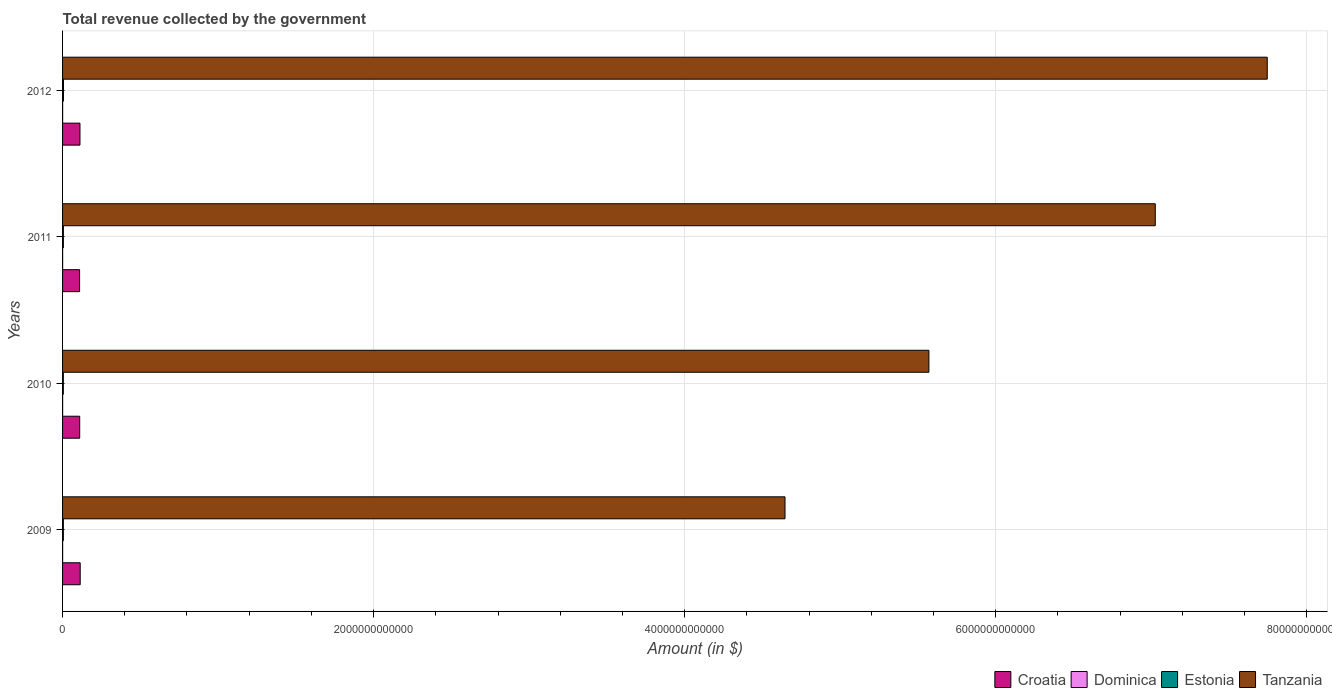Are the number of bars per tick equal to the number of legend labels?
Your answer should be very brief. Yes. What is the label of the 3rd group of bars from the top?
Offer a very short reply. 2010. What is the total revenue collected by the government in Estonia in 2009?
Provide a succinct answer. 5.06e+09. Across all years, what is the maximum total revenue collected by the government in Dominica?
Make the answer very short. 3.57e+08. Across all years, what is the minimum total revenue collected by the government in Tanzania?
Provide a short and direct response. 4.65e+12. In which year was the total revenue collected by the government in Croatia minimum?
Give a very brief answer. 2011. What is the total total revenue collected by the government in Croatia in the graph?
Your response must be concise. 4.45e+11. What is the difference between the total revenue collected by the government in Estonia in 2009 and that in 2012?
Offer a terse response. -7.36e+08. What is the difference between the total revenue collected by the government in Croatia in 2010 and the total revenue collected by the government in Estonia in 2009?
Your answer should be compact. 1.05e+11. What is the average total revenue collected by the government in Dominica per year?
Ensure brevity in your answer.  3.52e+08. In the year 2011, what is the difference between the total revenue collected by the government in Dominica and total revenue collected by the government in Croatia?
Give a very brief answer. -1.09e+11. What is the ratio of the total revenue collected by the government in Dominica in 2010 to that in 2012?
Offer a terse response. 1.01. Is the total revenue collected by the government in Tanzania in 2010 less than that in 2012?
Your answer should be compact. Yes. Is the difference between the total revenue collected by the government in Dominica in 2010 and 2011 greater than the difference between the total revenue collected by the government in Croatia in 2010 and 2011?
Keep it short and to the point. No. What is the difference between the highest and the second highest total revenue collected by the government in Dominica?
Your answer should be very brief. 5.50e+06. What is the difference between the highest and the lowest total revenue collected by the government in Estonia?
Keep it short and to the point. 8.42e+08. In how many years, is the total revenue collected by the government in Croatia greater than the average total revenue collected by the government in Croatia taken over all years?
Keep it short and to the point. 2. Is it the case that in every year, the sum of the total revenue collected by the government in Croatia and total revenue collected by the government in Estonia is greater than the sum of total revenue collected by the government in Dominica and total revenue collected by the government in Tanzania?
Your response must be concise. No. What does the 1st bar from the top in 2011 represents?
Offer a very short reply. Tanzania. What does the 4th bar from the bottom in 2009 represents?
Your response must be concise. Tanzania. Is it the case that in every year, the sum of the total revenue collected by the government in Estonia and total revenue collected by the government in Tanzania is greater than the total revenue collected by the government in Croatia?
Provide a succinct answer. Yes. How many bars are there?
Offer a terse response. 16. How many years are there in the graph?
Provide a succinct answer. 4. What is the difference between two consecutive major ticks on the X-axis?
Give a very brief answer. 2.00e+12. What is the title of the graph?
Provide a succinct answer. Total revenue collected by the government. Does "Latin America(developing only)" appear as one of the legend labels in the graph?
Your answer should be very brief. No. What is the label or title of the X-axis?
Keep it short and to the point. Amount (in $). What is the Amount (in $) in Croatia in 2009?
Offer a very short reply. 1.13e+11. What is the Amount (in $) in Dominica in 2009?
Your response must be concise. 3.50e+08. What is the Amount (in $) in Estonia in 2009?
Keep it short and to the point. 5.06e+09. What is the Amount (in $) of Tanzania in 2009?
Provide a short and direct response. 4.65e+12. What is the Amount (in $) in Croatia in 2010?
Give a very brief answer. 1.10e+11. What is the Amount (in $) in Dominica in 2010?
Keep it short and to the point. 3.52e+08. What is the Amount (in $) of Estonia in 2010?
Give a very brief answer. 4.96e+09. What is the Amount (in $) of Tanzania in 2010?
Make the answer very short. 5.57e+12. What is the Amount (in $) of Croatia in 2011?
Offer a terse response. 1.10e+11. What is the Amount (in $) of Dominica in 2011?
Provide a short and direct response. 3.57e+08. What is the Amount (in $) in Estonia in 2011?
Make the answer very short. 5.31e+09. What is the Amount (in $) of Tanzania in 2011?
Give a very brief answer. 7.03e+12. What is the Amount (in $) in Croatia in 2012?
Make the answer very short. 1.12e+11. What is the Amount (in $) of Dominica in 2012?
Keep it short and to the point. 3.49e+08. What is the Amount (in $) in Estonia in 2012?
Provide a short and direct response. 5.80e+09. What is the Amount (in $) of Tanzania in 2012?
Offer a terse response. 7.75e+12. Across all years, what is the maximum Amount (in $) of Croatia?
Provide a short and direct response. 1.13e+11. Across all years, what is the maximum Amount (in $) of Dominica?
Provide a short and direct response. 3.57e+08. Across all years, what is the maximum Amount (in $) of Estonia?
Your answer should be very brief. 5.80e+09. Across all years, what is the maximum Amount (in $) in Tanzania?
Keep it short and to the point. 7.75e+12. Across all years, what is the minimum Amount (in $) in Croatia?
Provide a short and direct response. 1.10e+11. Across all years, what is the minimum Amount (in $) of Dominica?
Your answer should be compact. 3.49e+08. Across all years, what is the minimum Amount (in $) in Estonia?
Your answer should be compact. 4.96e+09. Across all years, what is the minimum Amount (in $) in Tanzania?
Make the answer very short. 4.65e+12. What is the total Amount (in $) in Croatia in the graph?
Offer a very short reply. 4.45e+11. What is the total Amount (in $) in Dominica in the graph?
Make the answer very short. 1.41e+09. What is the total Amount (in $) of Estonia in the graph?
Ensure brevity in your answer.  2.11e+1. What is the total Amount (in $) in Tanzania in the graph?
Keep it short and to the point. 2.50e+13. What is the difference between the Amount (in $) in Croatia in 2009 and that in 2010?
Your answer should be very brief. 3.26e+09. What is the difference between the Amount (in $) in Dominica in 2009 and that in 2010?
Offer a terse response. -1.80e+06. What is the difference between the Amount (in $) in Estonia in 2009 and that in 2010?
Your answer should be compact. 1.06e+08. What is the difference between the Amount (in $) in Tanzania in 2009 and that in 2010?
Offer a terse response. -9.25e+11. What is the difference between the Amount (in $) in Croatia in 2009 and that in 2011?
Keep it short and to the point. 3.93e+09. What is the difference between the Amount (in $) in Dominica in 2009 and that in 2011?
Provide a short and direct response. -7.30e+06. What is the difference between the Amount (in $) of Estonia in 2009 and that in 2011?
Offer a very short reply. -2.50e+08. What is the difference between the Amount (in $) in Tanzania in 2009 and that in 2011?
Ensure brevity in your answer.  -2.38e+12. What is the difference between the Amount (in $) of Croatia in 2009 and that in 2012?
Offer a very short reply. 1.54e+09. What is the difference between the Amount (in $) in Estonia in 2009 and that in 2012?
Your answer should be compact. -7.36e+08. What is the difference between the Amount (in $) in Tanzania in 2009 and that in 2012?
Make the answer very short. -3.10e+12. What is the difference between the Amount (in $) of Croatia in 2010 and that in 2011?
Your answer should be very brief. 6.73e+08. What is the difference between the Amount (in $) of Dominica in 2010 and that in 2011?
Provide a succinct answer. -5.50e+06. What is the difference between the Amount (in $) of Estonia in 2010 and that in 2011?
Your answer should be very brief. -3.56e+08. What is the difference between the Amount (in $) of Tanzania in 2010 and that in 2011?
Your answer should be compact. -1.46e+12. What is the difference between the Amount (in $) of Croatia in 2010 and that in 2012?
Your answer should be very brief. -1.72e+09. What is the difference between the Amount (in $) in Dominica in 2010 and that in 2012?
Give a very brief answer. 2.60e+06. What is the difference between the Amount (in $) of Estonia in 2010 and that in 2012?
Give a very brief answer. -8.42e+08. What is the difference between the Amount (in $) in Tanzania in 2010 and that in 2012?
Your answer should be compact. -2.18e+12. What is the difference between the Amount (in $) in Croatia in 2011 and that in 2012?
Your response must be concise. -2.40e+09. What is the difference between the Amount (in $) in Dominica in 2011 and that in 2012?
Give a very brief answer. 8.10e+06. What is the difference between the Amount (in $) of Estonia in 2011 and that in 2012?
Give a very brief answer. -4.86e+08. What is the difference between the Amount (in $) in Tanzania in 2011 and that in 2012?
Make the answer very short. -7.20e+11. What is the difference between the Amount (in $) of Croatia in 2009 and the Amount (in $) of Dominica in 2010?
Provide a succinct answer. 1.13e+11. What is the difference between the Amount (in $) in Croatia in 2009 and the Amount (in $) in Estonia in 2010?
Offer a very short reply. 1.08e+11. What is the difference between the Amount (in $) in Croatia in 2009 and the Amount (in $) in Tanzania in 2010?
Offer a very short reply. -5.46e+12. What is the difference between the Amount (in $) of Dominica in 2009 and the Amount (in $) of Estonia in 2010?
Make the answer very short. -4.61e+09. What is the difference between the Amount (in $) in Dominica in 2009 and the Amount (in $) in Tanzania in 2010?
Offer a terse response. -5.57e+12. What is the difference between the Amount (in $) in Estonia in 2009 and the Amount (in $) in Tanzania in 2010?
Your answer should be compact. -5.57e+12. What is the difference between the Amount (in $) of Croatia in 2009 and the Amount (in $) of Dominica in 2011?
Your answer should be very brief. 1.13e+11. What is the difference between the Amount (in $) of Croatia in 2009 and the Amount (in $) of Estonia in 2011?
Offer a very short reply. 1.08e+11. What is the difference between the Amount (in $) in Croatia in 2009 and the Amount (in $) in Tanzania in 2011?
Ensure brevity in your answer.  -6.91e+12. What is the difference between the Amount (in $) of Dominica in 2009 and the Amount (in $) of Estonia in 2011?
Your answer should be compact. -4.96e+09. What is the difference between the Amount (in $) of Dominica in 2009 and the Amount (in $) of Tanzania in 2011?
Provide a succinct answer. -7.03e+12. What is the difference between the Amount (in $) of Estonia in 2009 and the Amount (in $) of Tanzania in 2011?
Keep it short and to the point. -7.02e+12. What is the difference between the Amount (in $) of Croatia in 2009 and the Amount (in $) of Dominica in 2012?
Your answer should be compact. 1.13e+11. What is the difference between the Amount (in $) in Croatia in 2009 and the Amount (in $) in Estonia in 2012?
Offer a terse response. 1.08e+11. What is the difference between the Amount (in $) of Croatia in 2009 and the Amount (in $) of Tanzania in 2012?
Provide a short and direct response. -7.63e+12. What is the difference between the Amount (in $) of Dominica in 2009 and the Amount (in $) of Estonia in 2012?
Offer a terse response. -5.45e+09. What is the difference between the Amount (in $) of Dominica in 2009 and the Amount (in $) of Tanzania in 2012?
Your answer should be very brief. -7.75e+12. What is the difference between the Amount (in $) in Estonia in 2009 and the Amount (in $) in Tanzania in 2012?
Provide a short and direct response. -7.74e+12. What is the difference between the Amount (in $) of Croatia in 2010 and the Amount (in $) of Dominica in 2011?
Ensure brevity in your answer.  1.10e+11. What is the difference between the Amount (in $) of Croatia in 2010 and the Amount (in $) of Estonia in 2011?
Make the answer very short. 1.05e+11. What is the difference between the Amount (in $) of Croatia in 2010 and the Amount (in $) of Tanzania in 2011?
Your answer should be compact. -6.92e+12. What is the difference between the Amount (in $) in Dominica in 2010 and the Amount (in $) in Estonia in 2011?
Give a very brief answer. -4.96e+09. What is the difference between the Amount (in $) in Dominica in 2010 and the Amount (in $) in Tanzania in 2011?
Your response must be concise. -7.03e+12. What is the difference between the Amount (in $) of Estonia in 2010 and the Amount (in $) of Tanzania in 2011?
Offer a terse response. -7.02e+12. What is the difference between the Amount (in $) of Croatia in 2010 and the Amount (in $) of Dominica in 2012?
Your response must be concise. 1.10e+11. What is the difference between the Amount (in $) in Croatia in 2010 and the Amount (in $) in Estonia in 2012?
Your answer should be very brief. 1.04e+11. What is the difference between the Amount (in $) in Croatia in 2010 and the Amount (in $) in Tanzania in 2012?
Provide a short and direct response. -7.64e+12. What is the difference between the Amount (in $) of Dominica in 2010 and the Amount (in $) of Estonia in 2012?
Your answer should be very brief. -5.45e+09. What is the difference between the Amount (in $) of Dominica in 2010 and the Amount (in $) of Tanzania in 2012?
Your answer should be compact. -7.75e+12. What is the difference between the Amount (in $) in Estonia in 2010 and the Amount (in $) in Tanzania in 2012?
Offer a very short reply. -7.74e+12. What is the difference between the Amount (in $) of Croatia in 2011 and the Amount (in $) of Dominica in 2012?
Your response must be concise. 1.09e+11. What is the difference between the Amount (in $) in Croatia in 2011 and the Amount (in $) in Estonia in 2012?
Give a very brief answer. 1.04e+11. What is the difference between the Amount (in $) in Croatia in 2011 and the Amount (in $) in Tanzania in 2012?
Your response must be concise. -7.64e+12. What is the difference between the Amount (in $) of Dominica in 2011 and the Amount (in $) of Estonia in 2012?
Keep it short and to the point. -5.44e+09. What is the difference between the Amount (in $) in Dominica in 2011 and the Amount (in $) in Tanzania in 2012?
Offer a terse response. -7.75e+12. What is the difference between the Amount (in $) in Estonia in 2011 and the Amount (in $) in Tanzania in 2012?
Provide a short and direct response. -7.74e+12. What is the average Amount (in $) in Croatia per year?
Give a very brief answer. 1.11e+11. What is the average Amount (in $) in Dominica per year?
Make the answer very short. 3.52e+08. What is the average Amount (in $) of Estonia per year?
Offer a terse response. 5.28e+09. What is the average Amount (in $) of Tanzania per year?
Your answer should be very brief. 6.25e+12. In the year 2009, what is the difference between the Amount (in $) in Croatia and Amount (in $) in Dominica?
Your answer should be compact. 1.13e+11. In the year 2009, what is the difference between the Amount (in $) in Croatia and Amount (in $) in Estonia?
Your answer should be compact. 1.08e+11. In the year 2009, what is the difference between the Amount (in $) of Croatia and Amount (in $) of Tanzania?
Ensure brevity in your answer.  -4.53e+12. In the year 2009, what is the difference between the Amount (in $) in Dominica and Amount (in $) in Estonia?
Your answer should be very brief. -4.71e+09. In the year 2009, what is the difference between the Amount (in $) in Dominica and Amount (in $) in Tanzania?
Ensure brevity in your answer.  -4.64e+12. In the year 2009, what is the difference between the Amount (in $) in Estonia and Amount (in $) in Tanzania?
Offer a terse response. -4.64e+12. In the year 2010, what is the difference between the Amount (in $) in Croatia and Amount (in $) in Dominica?
Offer a terse response. 1.10e+11. In the year 2010, what is the difference between the Amount (in $) in Croatia and Amount (in $) in Estonia?
Make the answer very short. 1.05e+11. In the year 2010, what is the difference between the Amount (in $) of Croatia and Amount (in $) of Tanzania?
Ensure brevity in your answer.  -5.46e+12. In the year 2010, what is the difference between the Amount (in $) in Dominica and Amount (in $) in Estonia?
Your response must be concise. -4.60e+09. In the year 2010, what is the difference between the Amount (in $) of Dominica and Amount (in $) of Tanzania?
Offer a terse response. -5.57e+12. In the year 2010, what is the difference between the Amount (in $) of Estonia and Amount (in $) of Tanzania?
Your response must be concise. -5.57e+12. In the year 2011, what is the difference between the Amount (in $) of Croatia and Amount (in $) of Dominica?
Your answer should be very brief. 1.09e+11. In the year 2011, what is the difference between the Amount (in $) in Croatia and Amount (in $) in Estonia?
Your answer should be compact. 1.04e+11. In the year 2011, what is the difference between the Amount (in $) in Croatia and Amount (in $) in Tanzania?
Provide a short and direct response. -6.92e+12. In the year 2011, what is the difference between the Amount (in $) in Dominica and Amount (in $) in Estonia?
Your answer should be compact. -4.96e+09. In the year 2011, what is the difference between the Amount (in $) of Dominica and Amount (in $) of Tanzania?
Your answer should be very brief. -7.03e+12. In the year 2011, what is the difference between the Amount (in $) of Estonia and Amount (in $) of Tanzania?
Ensure brevity in your answer.  -7.02e+12. In the year 2012, what is the difference between the Amount (in $) of Croatia and Amount (in $) of Dominica?
Provide a succinct answer. 1.12e+11. In the year 2012, what is the difference between the Amount (in $) in Croatia and Amount (in $) in Estonia?
Offer a very short reply. 1.06e+11. In the year 2012, what is the difference between the Amount (in $) in Croatia and Amount (in $) in Tanzania?
Your answer should be compact. -7.63e+12. In the year 2012, what is the difference between the Amount (in $) in Dominica and Amount (in $) in Estonia?
Offer a very short reply. -5.45e+09. In the year 2012, what is the difference between the Amount (in $) in Dominica and Amount (in $) in Tanzania?
Your answer should be compact. -7.75e+12. In the year 2012, what is the difference between the Amount (in $) in Estonia and Amount (in $) in Tanzania?
Your response must be concise. -7.74e+12. What is the ratio of the Amount (in $) of Croatia in 2009 to that in 2010?
Offer a terse response. 1.03. What is the ratio of the Amount (in $) in Dominica in 2009 to that in 2010?
Offer a terse response. 0.99. What is the ratio of the Amount (in $) in Estonia in 2009 to that in 2010?
Ensure brevity in your answer.  1.02. What is the ratio of the Amount (in $) of Tanzania in 2009 to that in 2010?
Provide a succinct answer. 0.83. What is the ratio of the Amount (in $) in Croatia in 2009 to that in 2011?
Provide a short and direct response. 1.04. What is the ratio of the Amount (in $) in Dominica in 2009 to that in 2011?
Provide a succinct answer. 0.98. What is the ratio of the Amount (in $) of Estonia in 2009 to that in 2011?
Keep it short and to the point. 0.95. What is the ratio of the Amount (in $) of Tanzania in 2009 to that in 2011?
Your answer should be compact. 0.66. What is the ratio of the Amount (in $) in Croatia in 2009 to that in 2012?
Your response must be concise. 1.01. What is the ratio of the Amount (in $) in Estonia in 2009 to that in 2012?
Your answer should be very brief. 0.87. What is the ratio of the Amount (in $) in Tanzania in 2009 to that in 2012?
Your answer should be compact. 0.6. What is the ratio of the Amount (in $) in Croatia in 2010 to that in 2011?
Give a very brief answer. 1.01. What is the ratio of the Amount (in $) of Dominica in 2010 to that in 2011?
Make the answer very short. 0.98. What is the ratio of the Amount (in $) in Estonia in 2010 to that in 2011?
Provide a short and direct response. 0.93. What is the ratio of the Amount (in $) in Tanzania in 2010 to that in 2011?
Provide a short and direct response. 0.79. What is the ratio of the Amount (in $) in Croatia in 2010 to that in 2012?
Offer a terse response. 0.98. What is the ratio of the Amount (in $) of Dominica in 2010 to that in 2012?
Provide a succinct answer. 1.01. What is the ratio of the Amount (in $) of Estonia in 2010 to that in 2012?
Provide a short and direct response. 0.85. What is the ratio of the Amount (in $) in Tanzania in 2010 to that in 2012?
Your answer should be very brief. 0.72. What is the ratio of the Amount (in $) in Croatia in 2011 to that in 2012?
Offer a terse response. 0.98. What is the ratio of the Amount (in $) of Dominica in 2011 to that in 2012?
Your answer should be compact. 1.02. What is the ratio of the Amount (in $) of Estonia in 2011 to that in 2012?
Give a very brief answer. 0.92. What is the ratio of the Amount (in $) in Tanzania in 2011 to that in 2012?
Make the answer very short. 0.91. What is the difference between the highest and the second highest Amount (in $) of Croatia?
Provide a succinct answer. 1.54e+09. What is the difference between the highest and the second highest Amount (in $) of Dominica?
Your answer should be compact. 5.50e+06. What is the difference between the highest and the second highest Amount (in $) of Estonia?
Offer a very short reply. 4.86e+08. What is the difference between the highest and the second highest Amount (in $) in Tanzania?
Your response must be concise. 7.20e+11. What is the difference between the highest and the lowest Amount (in $) of Croatia?
Provide a succinct answer. 3.93e+09. What is the difference between the highest and the lowest Amount (in $) in Dominica?
Keep it short and to the point. 8.10e+06. What is the difference between the highest and the lowest Amount (in $) in Estonia?
Keep it short and to the point. 8.42e+08. What is the difference between the highest and the lowest Amount (in $) of Tanzania?
Provide a short and direct response. 3.10e+12. 